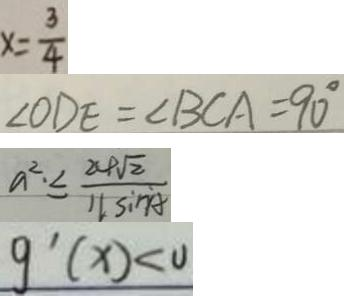<formula> <loc_0><loc_0><loc_500><loc_500>x = \frac { 3 } { 4 } 
 \angle O D E = \angle B C A = 9 0 ^ { \circ } 
 a ^ { 2 } . \leq \frac { 2 4 \sqrt { 2 } } { 1 1 \sin A } 
 g ^ { \prime } ( x ) < 0</formula> 